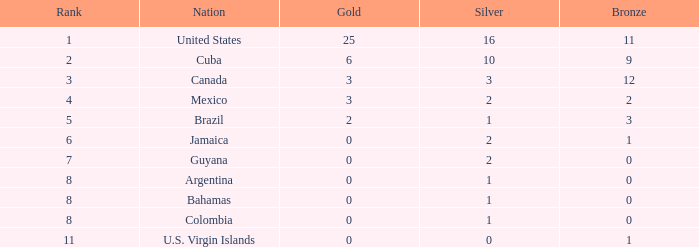What is the fewest number of silver medals a nation who ranked below 8 received? 0.0. 